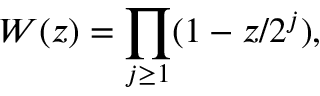<formula> <loc_0><loc_0><loc_500><loc_500>W ( z ) = \prod _ { j \geq 1 } ( 1 - z / 2 ^ { j } ) ,</formula> 